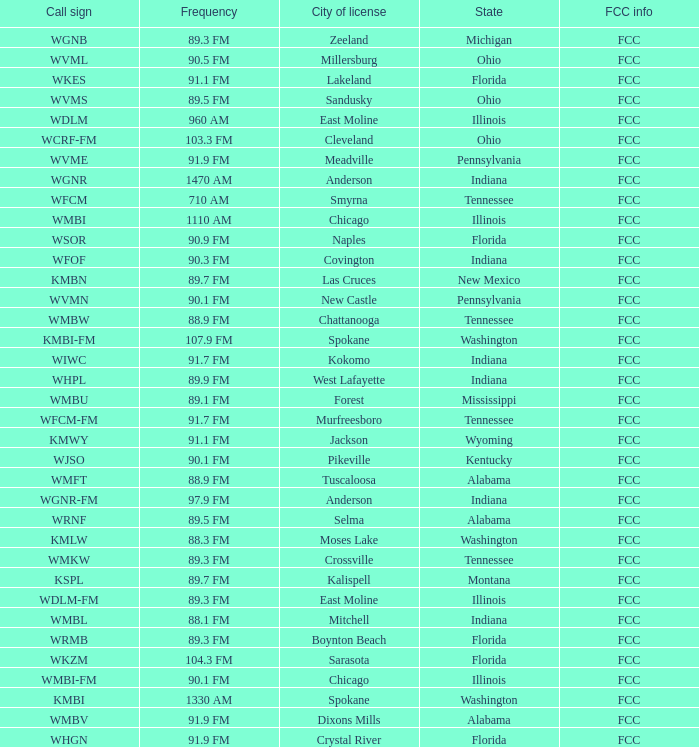Parse the full table. {'header': ['Call sign', 'Frequency', 'City of license', 'State', 'FCC info'], 'rows': [['WGNB', '89.3 FM', 'Zeeland', 'Michigan', 'FCC'], ['WVML', '90.5 FM', 'Millersburg', 'Ohio', 'FCC'], ['WKES', '91.1 FM', 'Lakeland', 'Florida', 'FCC'], ['WVMS', '89.5 FM', 'Sandusky', 'Ohio', 'FCC'], ['WDLM', '960 AM', 'East Moline', 'Illinois', 'FCC'], ['WCRF-FM', '103.3 FM', 'Cleveland', 'Ohio', 'FCC'], ['WVME', '91.9 FM', 'Meadville', 'Pennsylvania', 'FCC'], ['WGNR', '1470 AM', 'Anderson', 'Indiana', 'FCC'], ['WFCM', '710 AM', 'Smyrna', 'Tennessee', 'FCC'], ['WMBI', '1110 AM', 'Chicago', 'Illinois', 'FCC'], ['WSOR', '90.9 FM', 'Naples', 'Florida', 'FCC'], ['WFOF', '90.3 FM', 'Covington', 'Indiana', 'FCC'], ['KMBN', '89.7 FM', 'Las Cruces', 'New Mexico', 'FCC'], ['WVMN', '90.1 FM', 'New Castle', 'Pennsylvania', 'FCC'], ['WMBW', '88.9 FM', 'Chattanooga', 'Tennessee', 'FCC'], ['KMBI-FM', '107.9 FM', 'Spokane', 'Washington', 'FCC'], ['WIWC', '91.7 FM', 'Kokomo', 'Indiana', 'FCC'], ['WHPL', '89.9 FM', 'West Lafayette', 'Indiana', 'FCC'], ['WMBU', '89.1 FM', 'Forest', 'Mississippi', 'FCC'], ['WFCM-FM', '91.7 FM', 'Murfreesboro', 'Tennessee', 'FCC'], ['KMWY', '91.1 FM', 'Jackson', 'Wyoming', 'FCC'], ['WJSO', '90.1 FM', 'Pikeville', 'Kentucky', 'FCC'], ['WMFT', '88.9 FM', 'Tuscaloosa', 'Alabama', 'FCC'], ['WGNR-FM', '97.9 FM', 'Anderson', 'Indiana', 'FCC'], ['WRNF', '89.5 FM', 'Selma', 'Alabama', 'FCC'], ['KMLW', '88.3 FM', 'Moses Lake', 'Washington', 'FCC'], ['WMKW', '89.3 FM', 'Crossville', 'Tennessee', 'FCC'], ['KSPL', '89.7 FM', 'Kalispell', 'Montana', 'FCC'], ['WDLM-FM', '89.3 FM', 'East Moline', 'Illinois', 'FCC'], ['WMBL', '88.1 FM', 'Mitchell', 'Indiana', 'FCC'], ['WRMB', '89.3 FM', 'Boynton Beach', 'Florida', 'FCC'], ['WKZM', '104.3 FM', 'Sarasota', 'Florida', 'FCC'], ['WMBI-FM', '90.1 FM', 'Chicago', 'Illinois', 'FCC'], ['KMBI', '1330 AM', 'Spokane', 'Washington', 'FCC'], ['WMBV', '91.9 FM', 'Dixons Mills', 'Alabama', 'FCC'], ['WHGN', '91.9 FM', 'Crystal River', 'Florida', 'FCC']]} What is the frequency of the radio station with a call sign of WGNR-FM? 97.9 FM. 